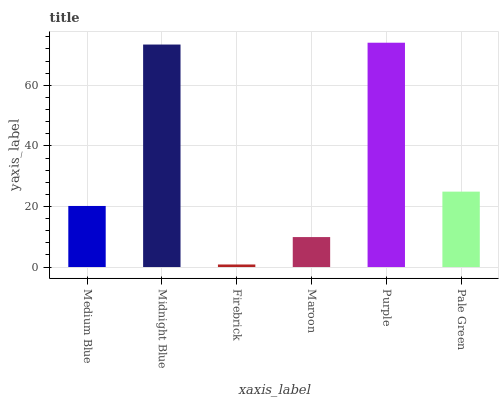Is Firebrick the minimum?
Answer yes or no. Yes. Is Purple the maximum?
Answer yes or no. Yes. Is Midnight Blue the minimum?
Answer yes or no. No. Is Midnight Blue the maximum?
Answer yes or no. No. Is Midnight Blue greater than Medium Blue?
Answer yes or no. Yes. Is Medium Blue less than Midnight Blue?
Answer yes or no. Yes. Is Medium Blue greater than Midnight Blue?
Answer yes or no. No. Is Midnight Blue less than Medium Blue?
Answer yes or no. No. Is Pale Green the high median?
Answer yes or no. Yes. Is Medium Blue the low median?
Answer yes or no. Yes. Is Firebrick the high median?
Answer yes or no. No. Is Maroon the low median?
Answer yes or no. No. 